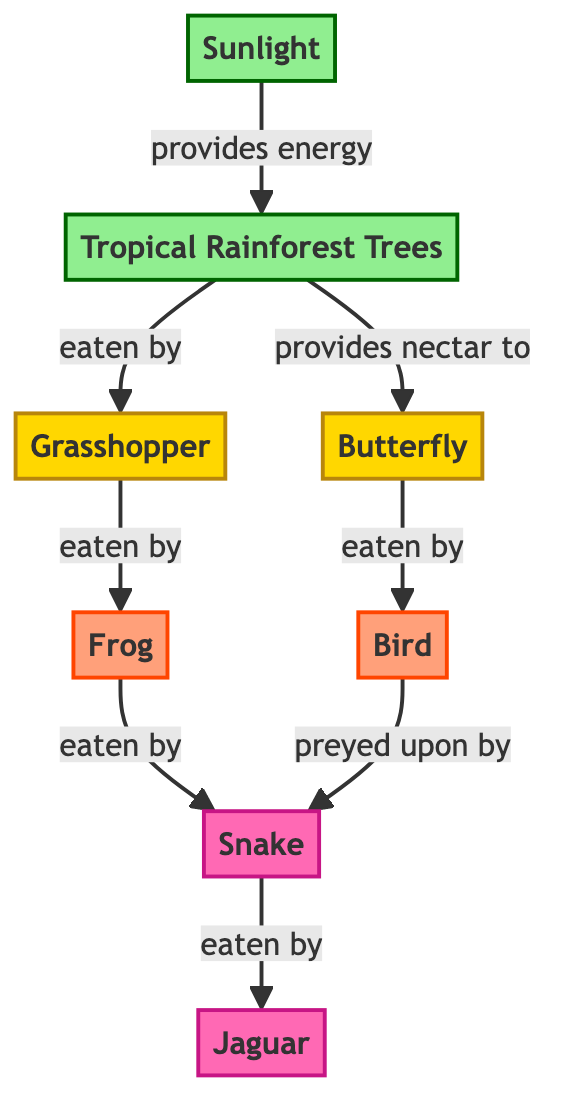What is the producer in this food web? The only node identified as a producer in the diagram is "Tropical Rainforest Trees," which receives energy from "Sunlight."
Answer: Tropical Rainforest Trees How many secondary consumers are there in the food web? There are two secondary consumers, "Frog" and "Bird," that are eaten by a tertiary consumer, which is "Snake."
Answer: 2 What do grasshoppers eat? The diagram indicates that "Grasshopper" eats "Tropical Rainforest Trees," making it clear that this is the primary source of its food in the diagram.
Answer: Tropical Rainforest Trees Which two animals are tertiary consumers? The tertiary consumers are "Snake" and "Jaguar," both of which are at the top of the predator hierarchy in this food web.
Answer: Snake, Jaguar What is the relationship between butterflies and birds? The diagram illustrates that "Butterfly" provides nectar to "Bird," indicating a mutualistic relationship where the bird benefits from the nectar while butterflies are pollinated.
Answer: Provides nectar to How do snakes obtain energy in this food web? Snakes, which are tertiary consumers, get energy by preying upon both "Frog" and "Bird," making them the top predators in their respective trophic layers.
Answer: By eating Frog and Bird Which node provides energy to tropical rainforest trees? The "Sunlight" node is shown to provide energy to "Tropical Rainforest Trees," which is the primary producer in the ecosystem represented in the diagram.
Answer: Sunlight What do frogs eat? From the flowchart, it is evident that "Frog" eats "Grasshopper," making this the answer to what species occupy the role in the food web.
Answer: Grasshopper How many total nodes are there in this food web? The food web has eight distinct nodes, comprising both producers and consumers: Sunlight, Tropical Rainforest Trees, Grasshopper, Butterfly, Frog, Bird, Snake, and Jaguar.
Answer: 8 